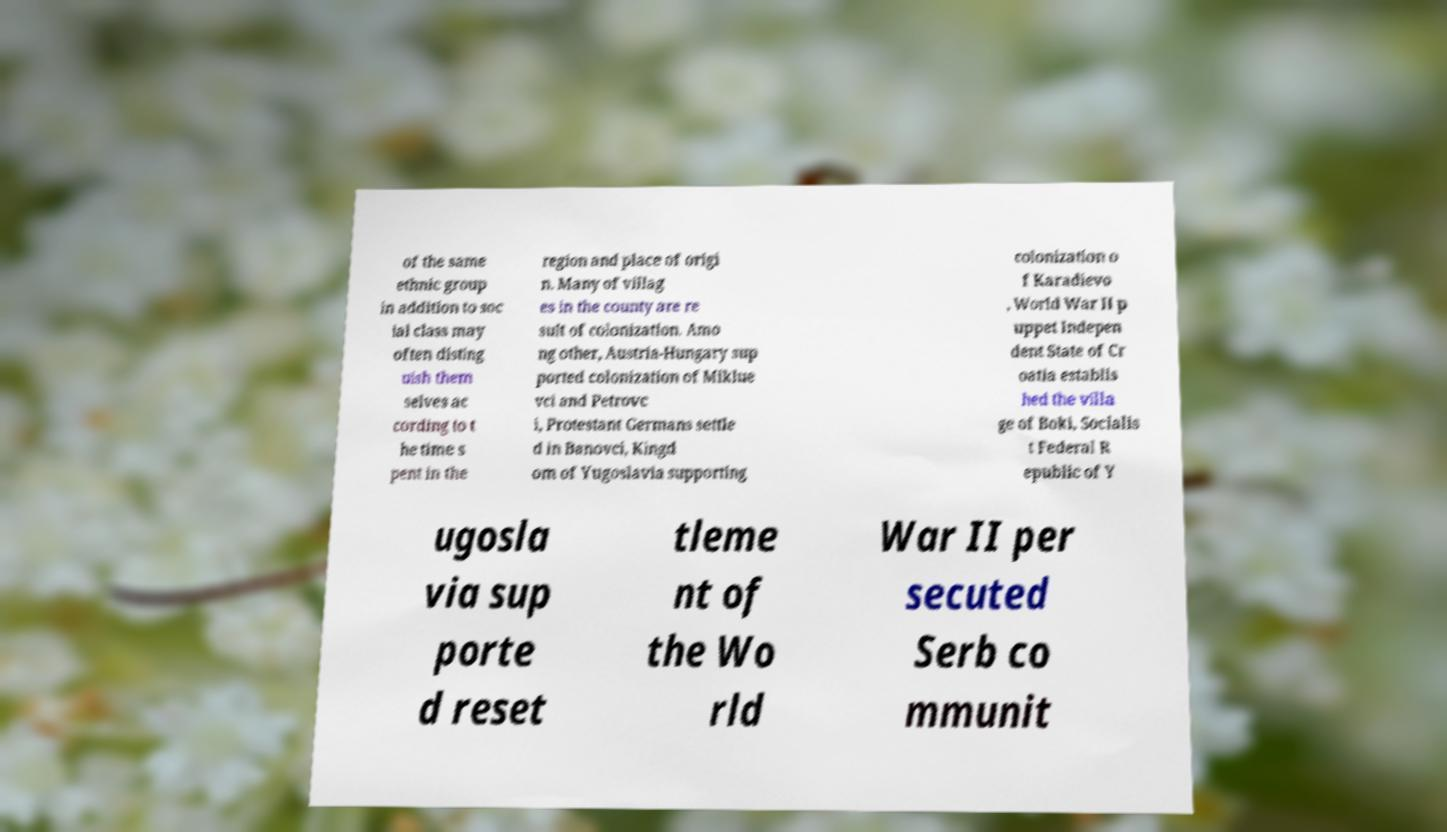I need the written content from this picture converted into text. Can you do that? of the same ethnic group in addition to soc ial class may often disting uish them selves ac cording to t he time s pent in the region and place of origi n. Many of villag es in the county are re sult of colonization. Amo ng other, Austria-Hungary sup ported colonization of Miklue vci and Petrovc i, Protestant Germans settle d in Banovci, Kingd om of Yugoslavia supporting colonization o f Karadievo , World War II p uppet Indepen dent State of Cr oatia establis hed the villa ge of Boki, Socialis t Federal R epublic of Y ugosla via sup porte d reset tleme nt of the Wo rld War II per secuted Serb co mmunit 